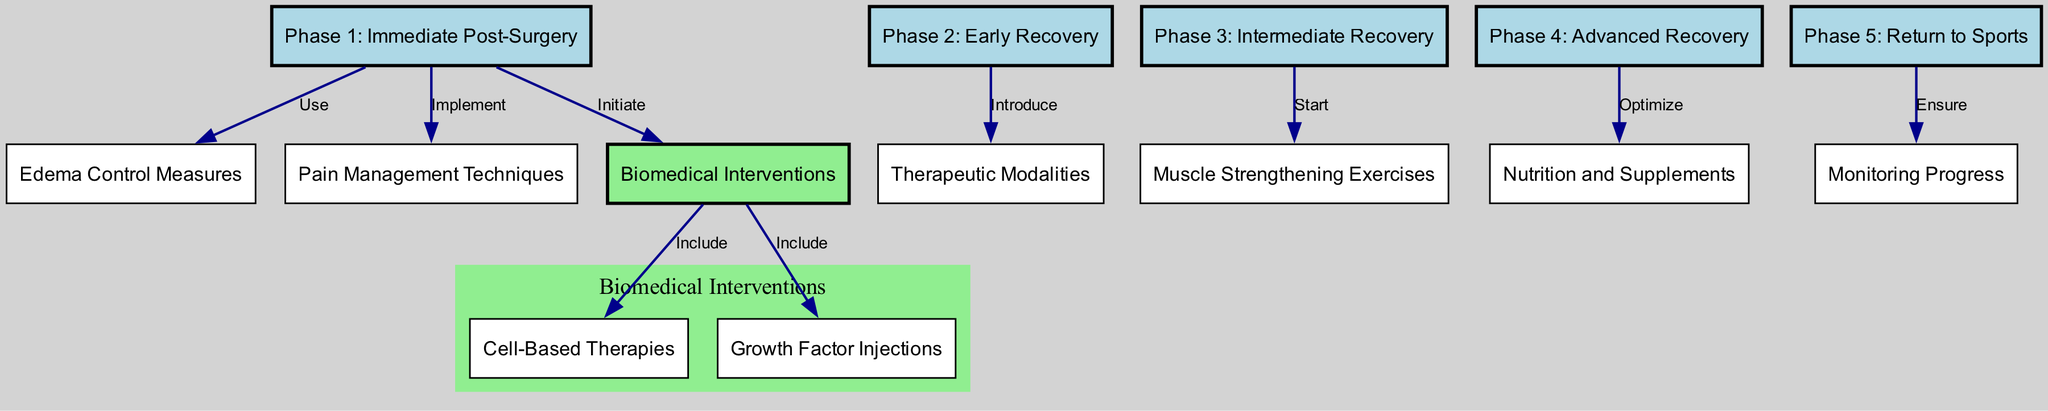What are the five recovery phases listed in the diagram? The diagram explicitly lists five phases of recovery: Immediate Post-Surgery, Early Recovery, Intermediate Recovery, Advanced Recovery, and Return to Sports. These phases are represented as distinct nodes labeled accordingly.
Answer: Immediate Post-Surgery, Early Recovery, Intermediate Recovery, Advanced Recovery, Return to Sports Which phase is associated with pain management techniques? Pain management techniques are specifically linked to Phase 1: Immediate Post-Surgery as indicated by the directed edge that shows the implementation relationship between these two nodes.
Answer: Phase 1: Immediate Post-Surgery How many biomedical interventions are included in the diagram? The diagram features three specific biomedical interventions which are: Cell-Based Therapies, Growth Factor Injections, and the general node titled Biomedical Interventions, indicating that these two therapies are part of that broader category.
Answer: 2 In which phase do muscle strengthening exercises start? Muscle strengthening exercises are indicated to start in Phase 3: Intermediate Recovery according to the connecting edge from this phase to the muscle strengthening exercises node.
Answer: Phase 3: Intermediate Recovery What is the primary purpose of the nutrition and supplements node in relation to the recovery phases? The nutrition and supplements node is primarily optimized in Phase 4: Advanced Recovery, which shows that at this stage, nutritional aspects play a significant role in the overall recovery process.
Answer: Phase 4: Advanced Recovery 